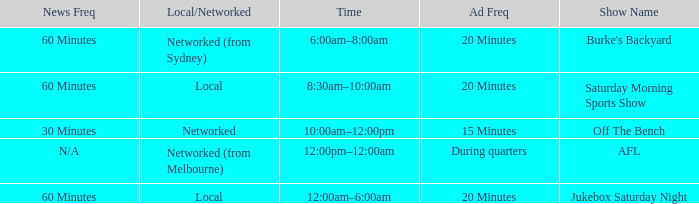What is the ad frequency for the Show Off The Bench? 15 Minutes. 